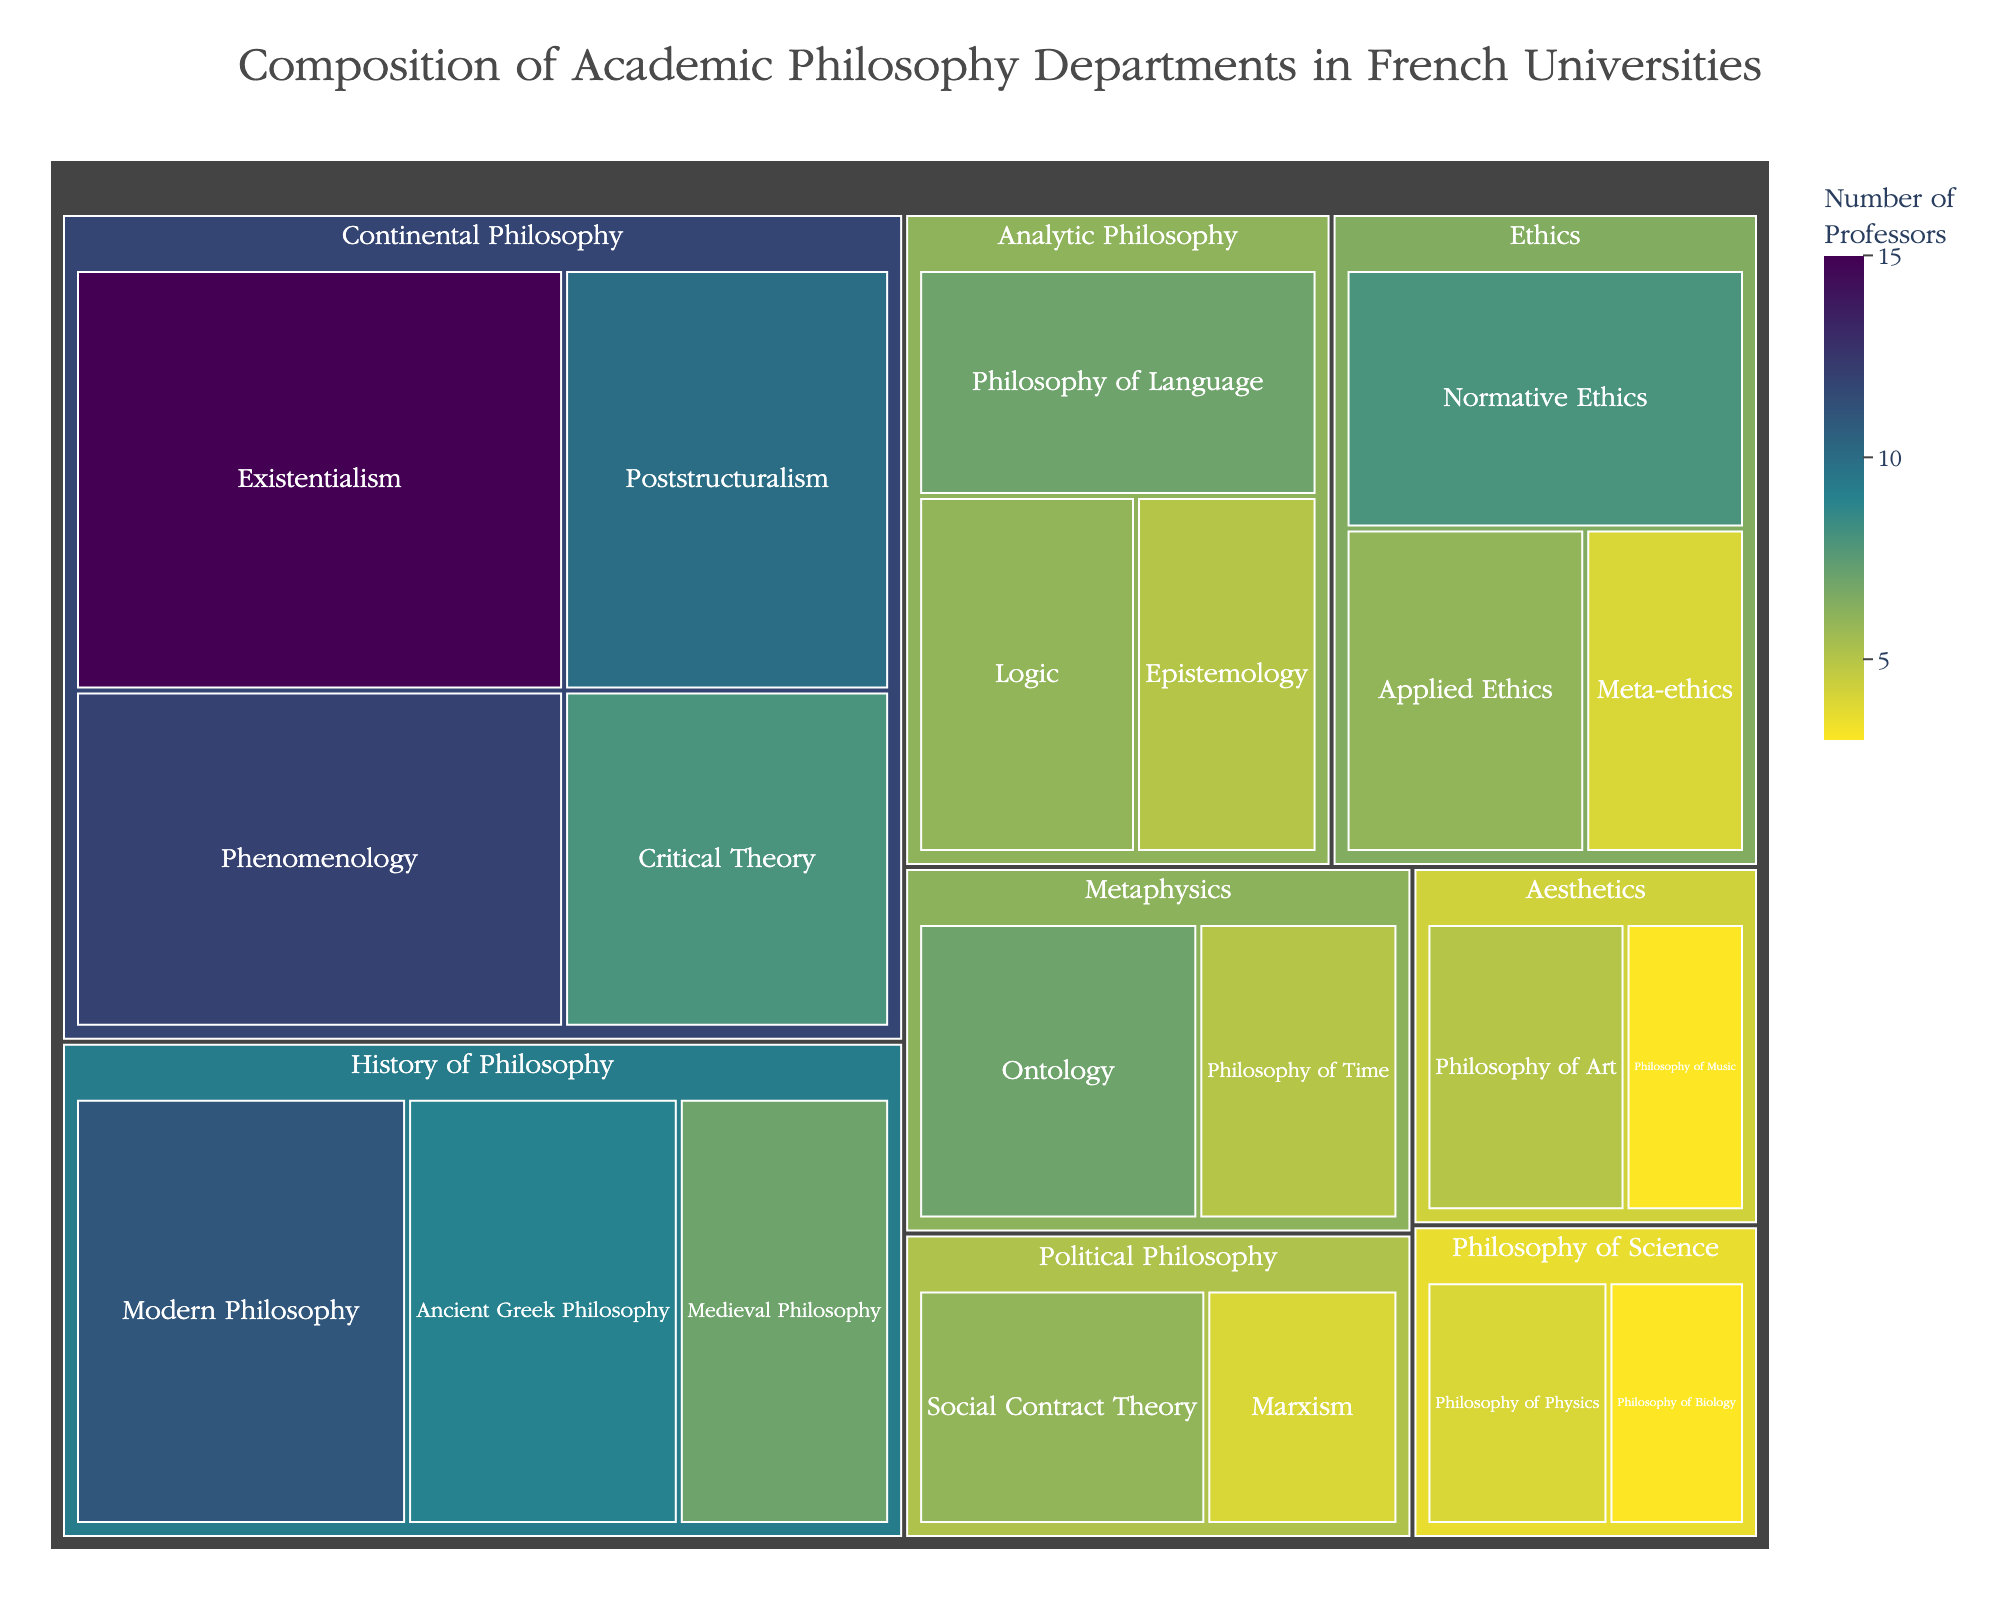Which area has the largest number of professors? The area with the largest number of professors is the largest segment of the treemap. According to the data, Continental Philosophy has 45 professors in total (15 Existentialism + 12 Phenomenology + 10 Poststructuralism + 8 Critical Theory). This is more than any other area.
Answer: Continental Philosophy How many professors specialize in Phenomenology? Locate the Continental Philosophy area in the treemap and then find the section labeled Phenomenology. The number of professors is displayed within that section.
Answer: 12 Which specialization in Ethics has the fewest professors? Locate the Ethics area in the treemap and compare the sections labeled Normative Ethics, Applied Ethics, and Meta-ethics. The section with the fewest professors is Meta-ethics.
Answer: Meta-ethics What's the total number of professors in the Analytic Philosophy area? Sum the number of professors in the specializations within Analytic Philosophy: 7 (Philosophy of Language) + 6 (Logic) + 5 (Epistemology).
Answer: 18 Compare the number of professors in Ancient Greek Philosophy and Medieval Philosophy. Which has more? Locate the History of Philosophy area and compare the sections for Ancient Greek Philosophy and Medieval Philosophy. Ancient Greek Philosophy has 9 professors, while Medieval Philosophy has 7.
Answer: Ancient Greek Philosophy Which area has more specializations: Metaphysics or Political Philosophy? Count the number of specializations in each area by locating the sections for Metaphysics and Political Philosophy in the treemap. Both Metaphysics and Political Philosophy have 2 specializations each.
Answer: Both have 2 What is the average number of professors per specialization in the Ethics area? Sum the number of professors in the Ethics area: 8 (Normative Ethics) + 6 (Applied Ethics) + 4 (Meta-ethics) = 18. There are 3 specializations, so the average is 18 / 3.
Answer: 6 Which specialization in Continental Philosophy has the least number of professors? In the Continental Philosophy area, compare the sections for Existentialism, Phenomenology, Poststructuralism, and Critical Theory. Critical Theory has the fewest professors.
Answer: Critical Theory How many professors are in the Philosophy of Science area? Sum the number of professors in the Philosophy of Science area: 4 (Philosophy of Physics) + 3 (Philosophy of Biology).
Answer: 7 Which has more professors: Philosophy of Time or Philosophy of Art? Locate the Metaphysics area for Philosophy of Time and the Aesthetics area for Philosophy of Art. Compare the number of professors in each section. Philosophy of Time has 5 professors, while Philosophy of Art has 5.
Answer: Both have 5 